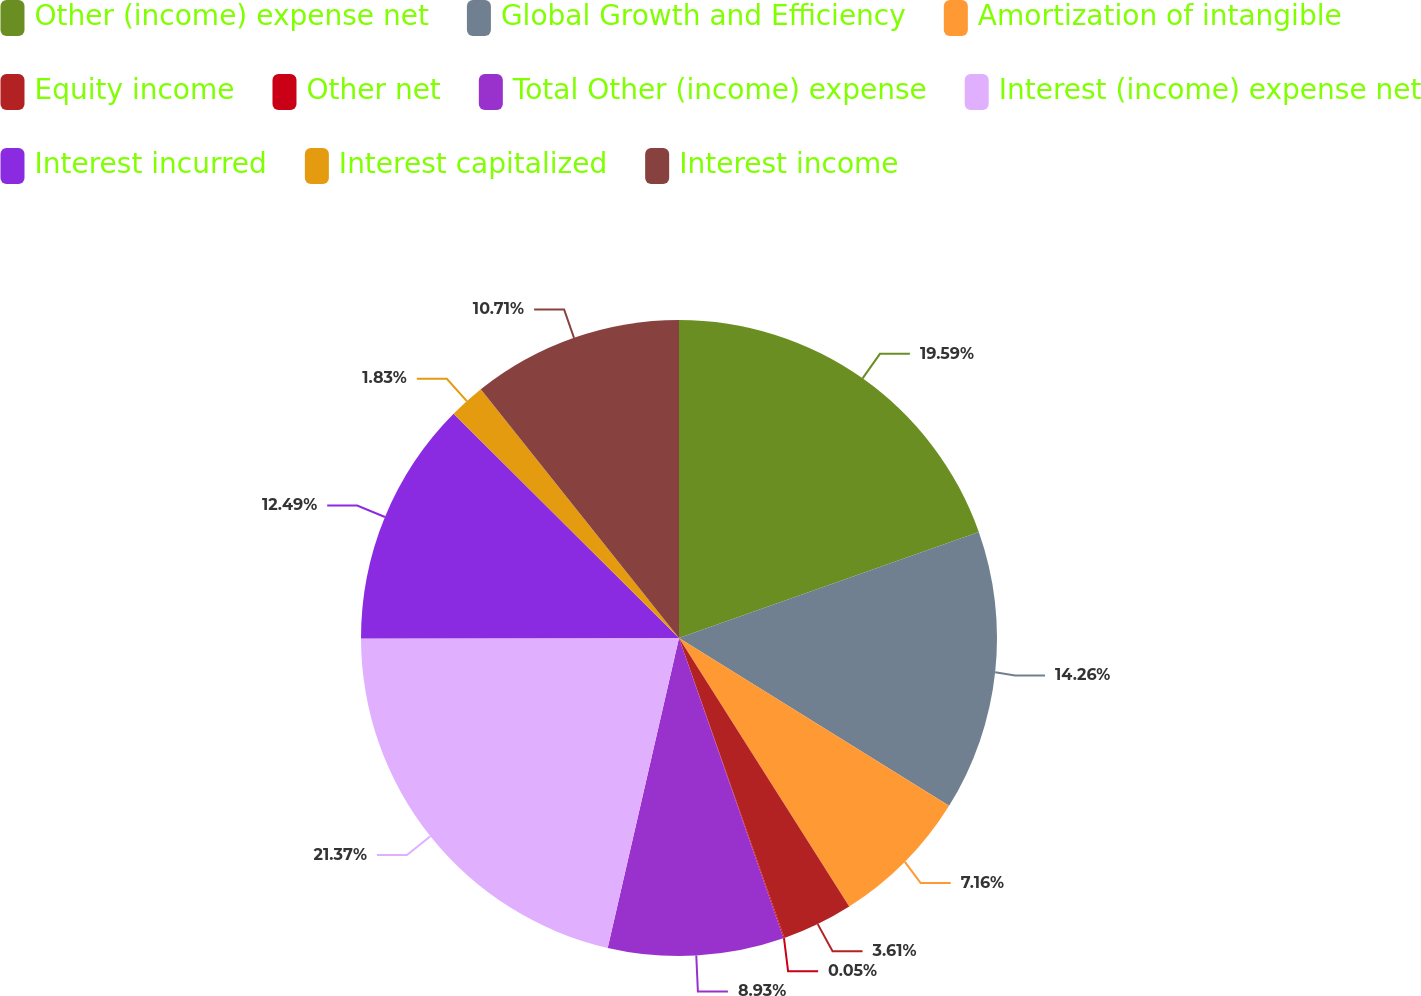<chart> <loc_0><loc_0><loc_500><loc_500><pie_chart><fcel>Other (income) expense net<fcel>Global Growth and Efficiency<fcel>Amortization of intangible<fcel>Equity income<fcel>Other net<fcel>Total Other (income) expense<fcel>Interest (income) expense net<fcel>Interest incurred<fcel>Interest capitalized<fcel>Interest income<nl><fcel>19.59%<fcel>14.26%<fcel>7.16%<fcel>3.61%<fcel>0.05%<fcel>8.93%<fcel>21.37%<fcel>12.49%<fcel>1.83%<fcel>10.71%<nl></chart> 